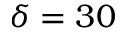Convert formula to latex. <formula><loc_0><loc_0><loc_500><loc_500>\delta = 3 0</formula> 